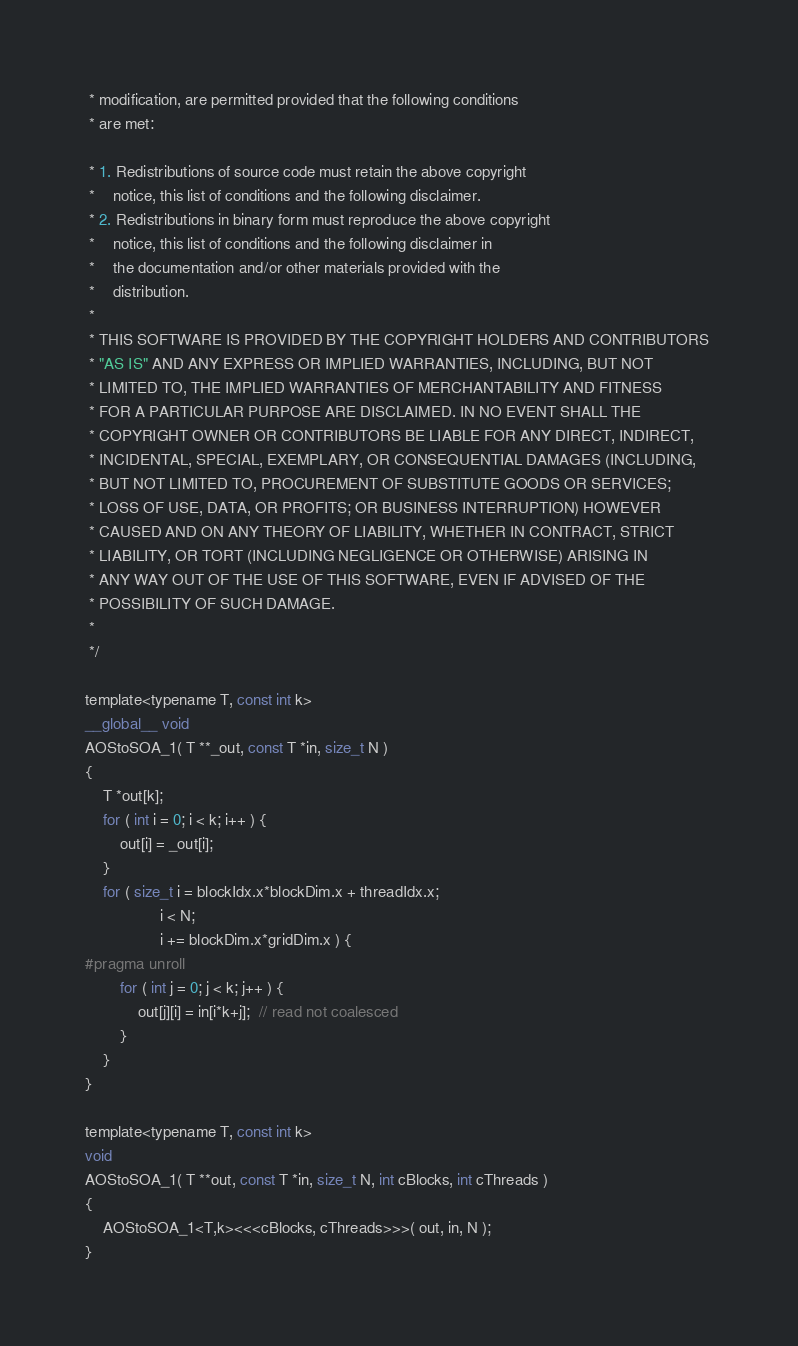<code> <loc_0><loc_0><loc_500><loc_500><_Cuda_> * modification, are permitted provided that the following conditions 
 * are met: 

 * 1. Redistributions of source code must retain the above copyright 
 *    notice, this list of conditions and the following disclaimer. 
 * 2. Redistributions in binary form must reproduce the above copyright 
 *    notice, this list of conditions and the following disclaimer in 
 *    the documentation and/or other materials provided with the 
 *    distribution. 
 *
 * THIS SOFTWARE IS PROVIDED BY THE COPYRIGHT HOLDERS AND CONTRIBUTORS 
 * "AS IS" AND ANY EXPRESS OR IMPLIED WARRANTIES, INCLUDING, BUT NOT 
 * LIMITED TO, THE IMPLIED WARRANTIES OF MERCHANTABILITY AND FITNESS 
 * FOR A PARTICULAR PURPOSE ARE DISCLAIMED. IN NO EVENT SHALL THE 
 * COPYRIGHT OWNER OR CONTRIBUTORS BE LIABLE FOR ANY DIRECT, INDIRECT, 
 * INCIDENTAL, SPECIAL, EXEMPLARY, OR CONSEQUENTIAL DAMAGES (INCLUDING, 
 * BUT NOT LIMITED TO, PROCUREMENT OF SUBSTITUTE GOODS OR SERVICES;
 * LOSS OF USE, DATA, OR PROFITS; OR BUSINESS INTERRUPTION) HOWEVER 
 * CAUSED AND ON ANY THEORY OF LIABILITY, WHETHER IN CONTRACT, STRICT 
 * LIABILITY, OR TORT (INCLUDING NEGLIGENCE OR OTHERWISE) ARISING IN 
 * ANY WAY OUT OF THE USE OF THIS SOFTWARE, EVEN IF ADVISED OF THE 
 * POSSIBILITY OF SUCH DAMAGE.
 *
 */

template<typename T, const int k>
__global__ void
AOStoSOA_1( T **_out, const T *in, size_t N )
{
    T *out[k];
    for ( int i = 0; i < k; i++ ) {
        out[i] = _out[i];
    }
    for ( size_t i = blockIdx.x*blockDim.x + threadIdx.x;
                 i < N;
                 i += blockDim.x*gridDim.x ) {
#pragma unroll
        for ( int j = 0; j < k; j++ ) {
            out[j][i] = in[i*k+j];  // read not coalesced
        }		
    }
}

template<typename T, const int k>
void
AOStoSOA_1( T **out, const T *in, size_t N, int cBlocks, int cThreads )
{
    AOStoSOA_1<T,k><<<cBlocks, cThreads>>>( out, in, N );
}
</code> 